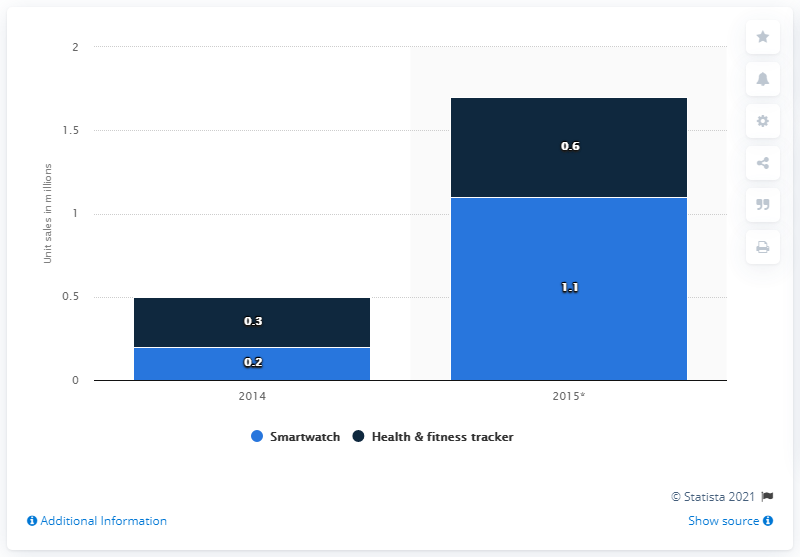Highlight a few significant elements in this photo. The forecast for the sale of smartwatches in the Middle East and Africa in 2015 is 1.1 million units. The highest value of the light blue bar is 1.1. In 2014, the number of wearables was the lowest among all years. 